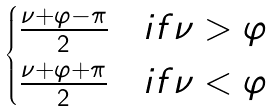<formula> <loc_0><loc_0><loc_500><loc_500>\begin{cases} \frac { \nu + \varphi - \pi } { 2 } & i f \nu > \varphi \\ \frac { \nu + \varphi + \pi } { 2 } & i f \nu < \varphi \end{cases}</formula> 